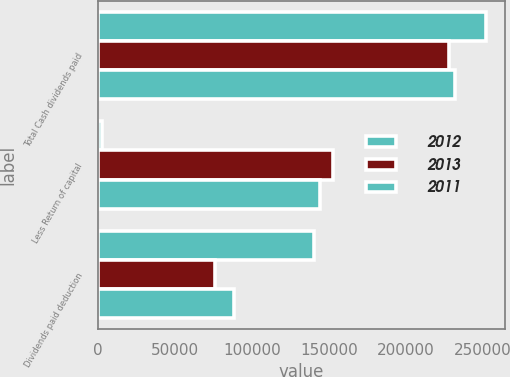Convert chart to OTSL. <chart><loc_0><loc_0><loc_500><loc_500><stacked_bar_chart><ecel><fcel>Total Cash dividends paid<fcel>Less Return of capital<fcel>Dividends paid deduction<nl><fcel>2012<fcel>251914<fcel>2507<fcel>140469<nl><fcel>2013<fcel>228330<fcel>152670<fcel>75660<nl><fcel>2011<fcel>232203<fcel>144208<fcel>87995<nl></chart> 